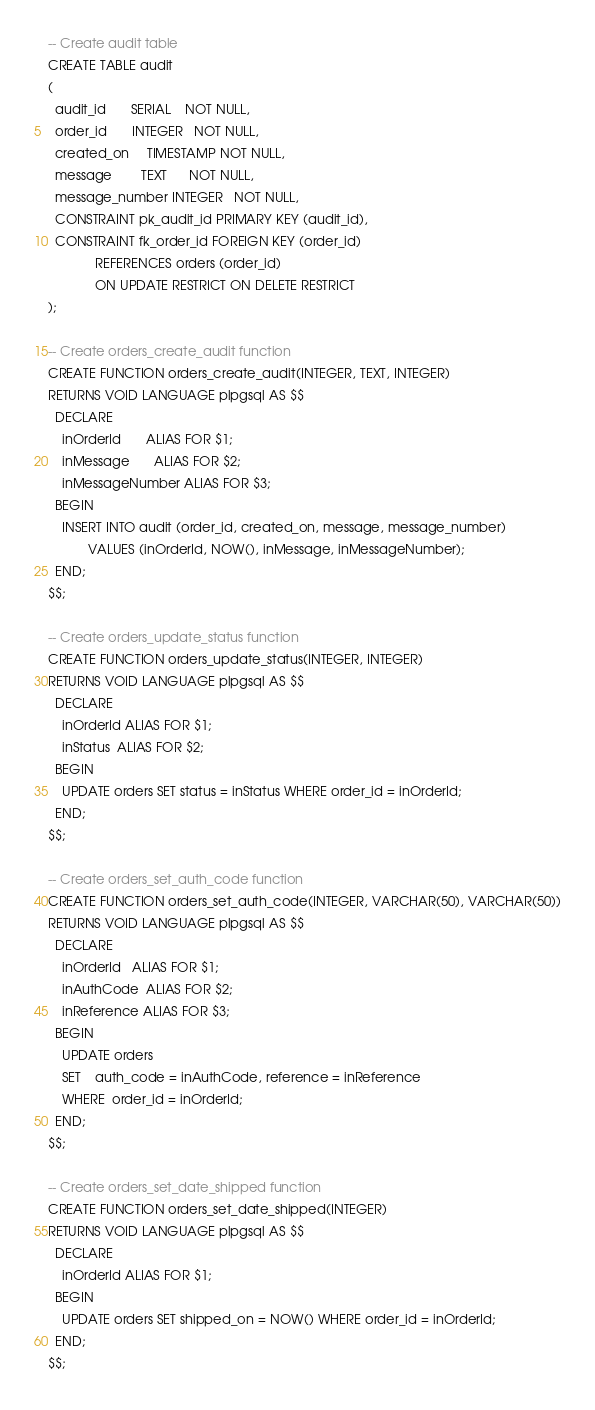<code> <loc_0><loc_0><loc_500><loc_500><_SQL_>-- Create audit table
CREATE TABLE audit
(
  audit_id       SERIAL    NOT NULL,
  order_id       INTEGER   NOT NULL,
  created_on     TIMESTAMP NOT NULL,
  message        TEXT      NOT NULL,
  message_number INTEGER   NOT NULL,
  CONSTRAINT pk_audit_id PRIMARY KEY (audit_id),
  CONSTRAINT fk_order_id FOREIGN KEY (order_id)
             REFERENCES orders (order_id)
             ON UPDATE RESTRICT ON DELETE RESTRICT
);

-- Create orders_create_audit function
CREATE FUNCTION orders_create_audit(INTEGER, TEXT, INTEGER)
RETURNS VOID LANGUAGE plpgsql AS $$
  DECLARE
    inOrderId       ALIAS FOR $1;
    inMessage       ALIAS FOR $2;
    inMessageNumber ALIAS FOR $3;
  BEGIN
    INSERT INTO audit (order_id, created_on, message, message_number)
           VALUES (inOrderId, NOW(), inMessage, inMessageNumber);
  END;
$$;

-- Create orders_update_status function
CREATE FUNCTION orders_update_status(INTEGER, INTEGER)
RETURNS VOID LANGUAGE plpgsql AS $$
  DECLARE
    inOrderId ALIAS FOR $1;
    inStatus  ALIAS FOR $2;
  BEGIN
    UPDATE orders SET status = inStatus WHERE order_id = inOrderId;
  END;
$$;

-- Create orders_set_auth_code function
CREATE FUNCTION orders_set_auth_code(INTEGER, VARCHAR(50), VARCHAR(50))
RETURNS VOID LANGUAGE plpgsql AS $$
  DECLARE
    inOrderId   ALIAS FOR $1;
    inAuthCode  ALIAS FOR $2;
    inReference ALIAS FOR $3;
  BEGIN
    UPDATE orders
    SET    auth_code = inAuthCode, reference = inReference
    WHERE  order_id = inOrderId;
  END;
$$;

-- Create orders_set_date_shipped function
CREATE FUNCTION orders_set_date_shipped(INTEGER)
RETURNS VOID LANGUAGE plpgsql AS $$
  DECLARE
    inOrderId ALIAS FOR $1;
  BEGIN
    UPDATE orders SET shipped_on = NOW() WHERE order_id = inOrderId;
  END;
$$;
</code> 